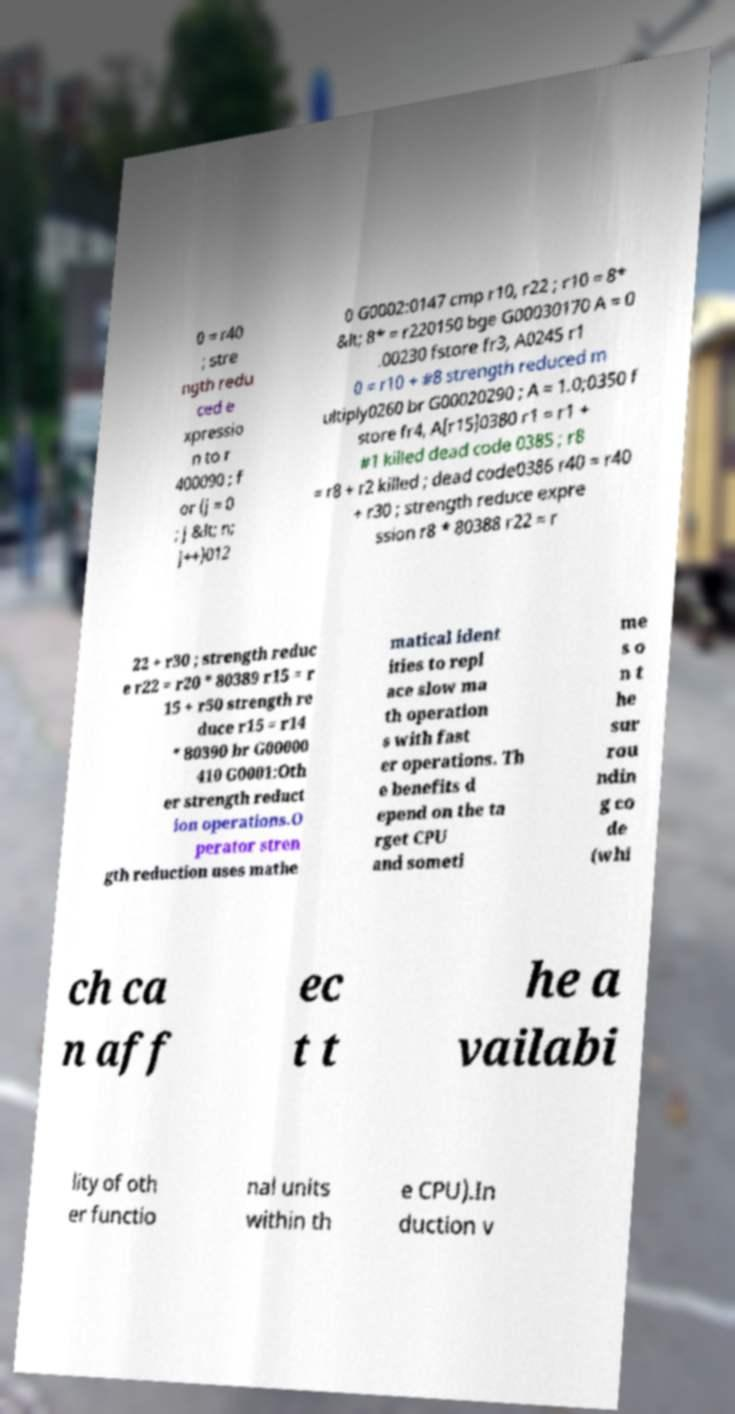Can you accurately transcribe the text from the provided image for me? 0 = r40 ; stre ngth redu ced e xpressio n to r 400090 ; f or (j = 0 ; j &lt; n; j++)012 0 G0002:0147 cmp r10, r22 ; r10 = 8* &lt; 8* = r220150 bge G00030170 A = 0 .00230 fstore fr3, A0245 r1 0 = r10 + #8 strength reduced m ultiply0260 br G00020290 ; A = 1.0;0350 f store fr4, A[r15]0380 r1 = r1 + #1 killed dead code 0385 ; r8 = r8 + r2 killed ; dead code0386 r40 = r40 + r30 ; strength reduce expre ssion r8 * 80388 r22 = r 22 + r30 ; strength reduc e r22 = r20 * 80389 r15 = r 15 + r50 strength re duce r15 = r14 * 80390 br G00000 410 G0001:Oth er strength reduct ion operations.O perator stren gth reduction uses mathe matical ident ities to repl ace slow ma th operation s with fast er operations. Th e benefits d epend on the ta rget CPU and someti me s o n t he sur rou ndin g co de (whi ch ca n aff ec t t he a vailabi lity of oth er functio nal units within th e CPU).In duction v 